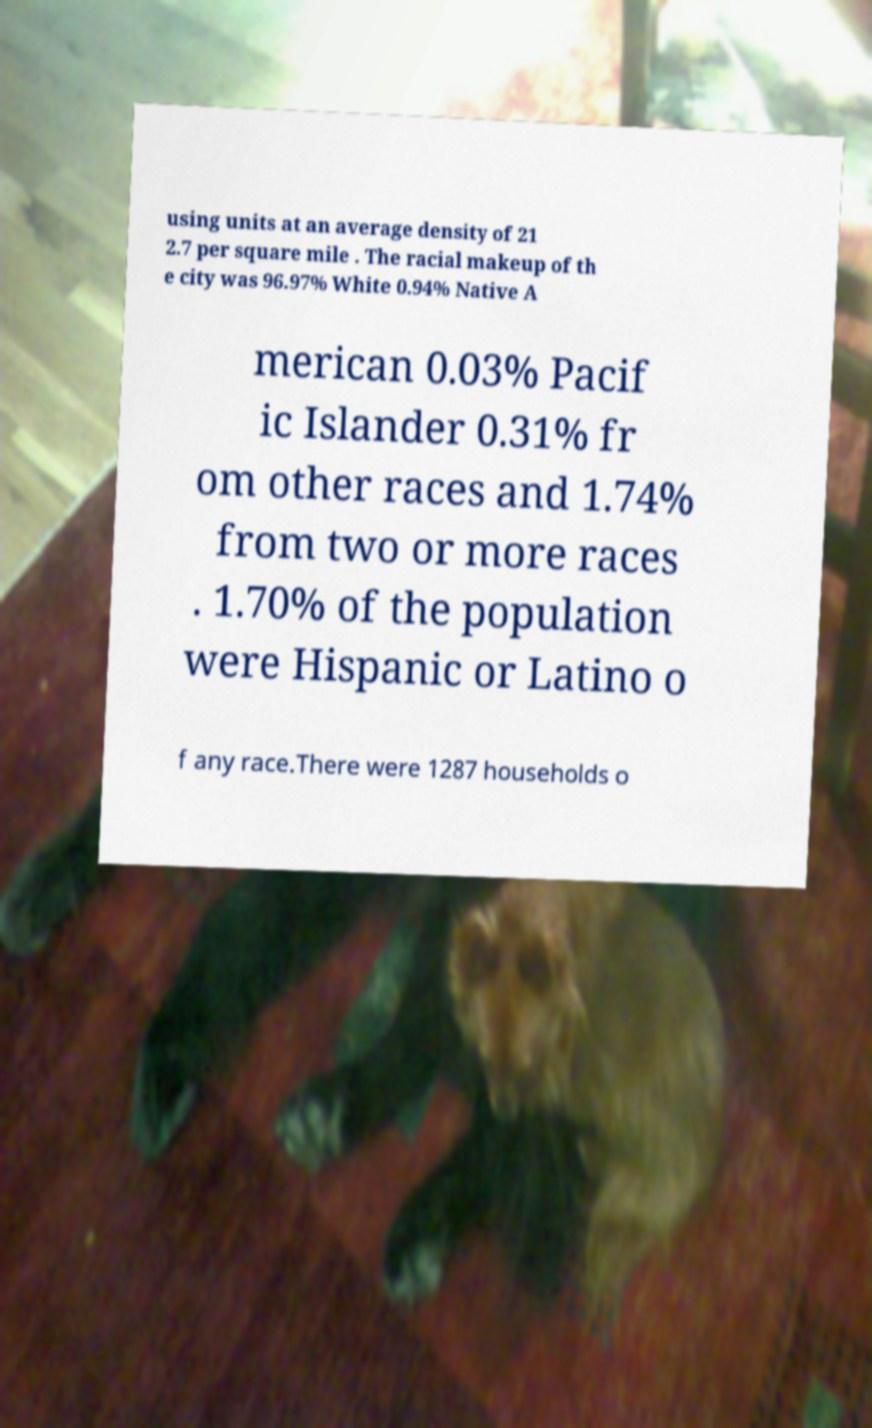What messages or text are displayed in this image? I need them in a readable, typed format. using units at an average density of 21 2.7 per square mile . The racial makeup of th e city was 96.97% White 0.94% Native A merican 0.03% Pacif ic Islander 0.31% fr om other races and 1.74% from two or more races . 1.70% of the population were Hispanic or Latino o f any race.There were 1287 households o 